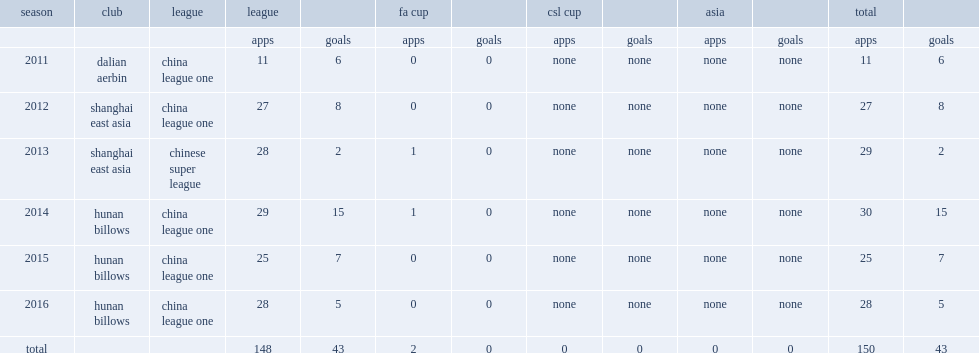Which club did luis carlos play for in 2011? Dalian aerbin. 